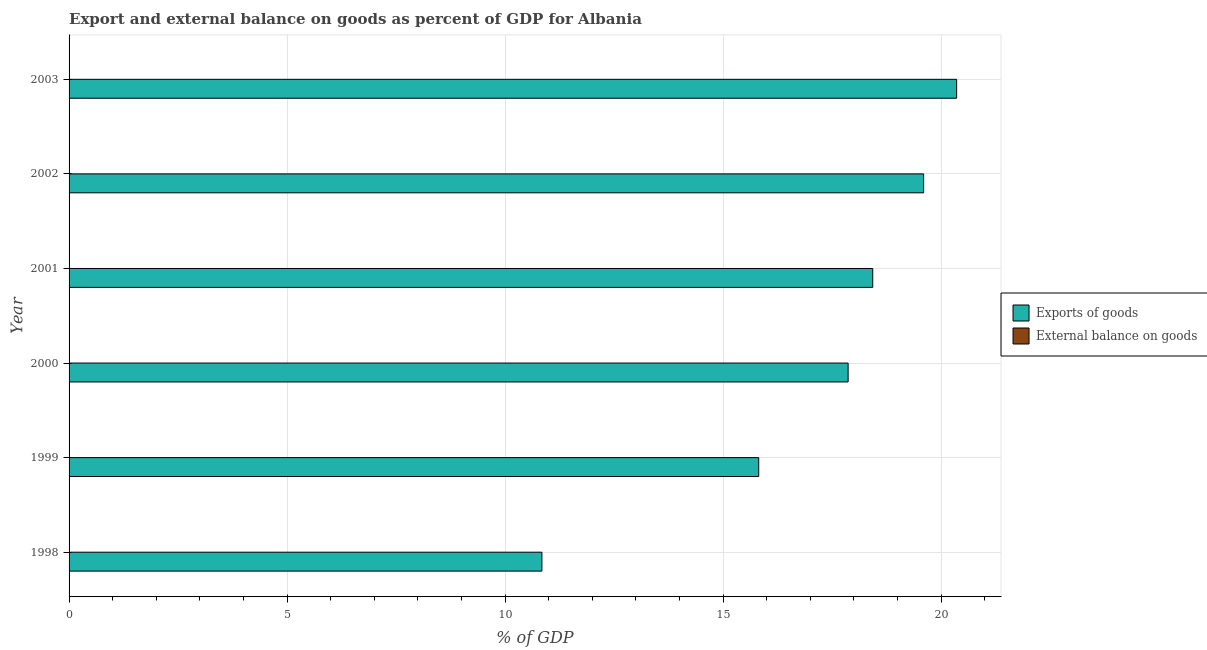Are the number of bars per tick equal to the number of legend labels?
Ensure brevity in your answer.  No. How many bars are there on the 5th tick from the top?
Keep it short and to the point. 1. What is the export of goods as percentage of gdp in 2002?
Offer a very short reply. 19.6. Across all years, what is the maximum export of goods as percentage of gdp?
Your answer should be compact. 20.36. In which year was the export of goods as percentage of gdp maximum?
Offer a very short reply. 2003. What is the total external balance on goods as percentage of gdp in the graph?
Provide a succinct answer. 0. What is the difference between the export of goods as percentage of gdp in 1999 and that in 2000?
Offer a terse response. -2.05. What is the difference between the external balance on goods as percentage of gdp in 2001 and the export of goods as percentage of gdp in 2002?
Provide a succinct answer. -19.6. What is the average export of goods as percentage of gdp per year?
Offer a terse response. 17.15. What is the ratio of the export of goods as percentage of gdp in 2000 to that in 2002?
Ensure brevity in your answer.  0.91. Is the export of goods as percentage of gdp in 2001 less than that in 2003?
Your answer should be compact. Yes. What is the difference between the highest and the second highest export of goods as percentage of gdp?
Offer a terse response. 0.76. What is the difference between the highest and the lowest export of goods as percentage of gdp?
Ensure brevity in your answer.  9.51. In how many years, is the export of goods as percentage of gdp greater than the average export of goods as percentage of gdp taken over all years?
Give a very brief answer. 4. Are all the bars in the graph horizontal?
Your answer should be compact. Yes. How many years are there in the graph?
Provide a succinct answer. 6. What is the difference between two consecutive major ticks on the X-axis?
Provide a succinct answer. 5. Does the graph contain any zero values?
Ensure brevity in your answer.  Yes. Where does the legend appear in the graph?
Provide a succinct answer. Center right. How many legend labels are there?
Provide a succinct answer. 2. How are the legend labels stacked?
Keep it short and to the point. Vertical. What is the title of the graph?
Provide a short and direct response. Export and external balance on goods as percent of GDP for Albania. What is the label or title of the X-axis?
Make the answer very short. % of GDP. What is the label or title of the Y-axis?
Your answer should be compact. Year. What is the % of GDP in Exports of goods in 1998?
Provide a succinct answer. 10.84. What is the % of GDP in External balance on goods in 1998?
Your answer should be very brief. 0. What is the % of GDP in Exports of goods in 1999?
Keep it short and to the point. 15.82. What is the % of GDP of External balance on goods in 1999?
Ensure brevity in your answer.  0. What is the % of GDP of Exports of goods in 2000?
Offer a very short reply. 17.87. What is the % of GDP of External balance on goods in 2000?
Your answer should be compact. 0. What is the % of GDP of Exports of goods in 2001?
Your answer should be very brief. 18.43. What is the % of GDP of External balance on goods in 2001?
Your answer should be compact. 0. What is the % of GDP of Exports of goods in 2002?
Give a very brief answer. 19.6. What is the % of GDP in External balance on goods in 2002?
Your answer should be very brief. 0. What is the % of GDP of Exports of goods in 2003?
Provide a short and direct response. 20.36. Across all years, what is the maximum % of GDP in Exports of goods?
Your answer should be very brief. 20.36. Across all years, what is the minimum % of GDP of Exports of goods?
Your answer should be compact. 10.84. What is the total % of GDP of Exports of goods in the graph?
Your answer should be compact. 102.91. What is the total % of GDP of External balance on goods in the graph?
Provide a succinct answer. 0. What is the difference between the % of GDP of Exports of goods in 1998 and that in 1999?
Your answer should be very brief. -4.97. What is the difference between the % of GDP in Exports of goods in 1998 and that in 2000?
Your response must be concise. -7.02. What is the difference between the % of GDP of Exports of goods in 1998 and that in 2001?
Your answer should be compact. -7.59. What is the difference between the % of GDP of Exports of goods in 1998 and that in 2002?
Make the answer very short. -8.75. What is the difference between the % of GDP in Exports of goods in 1998 and that in 2003?
Provide a succinct answer. -9.51. What is the difference between the % of GDP in Exports of goods in 1999 and that in 2000?
Offer a very short reply. -2.05. What is the difference between the % of GDP in Exports of goods in 1999 and that in 2001?
Offer a very short reply. -2.61. What is the difference between the % of GDP in Exports of goods in 1999 and that in 2002?
Keep it short and to the point. -3.78. What is the difference between the % of GDP of Exports of goods in 1999 and that in 2003?
Offer a terse response. -4.54. What is the difference between the % of GDP of Exports of goods in 2000 and that in 2001?
Make the answer very short. -0.56. What is the difference between the % of GDP in Exports of goods in 2000 and that in 2002?
Your response must be concise. -1.73. What is the difference between the % of GDP in Exports of goods in 2000 and that in 2003?
Keep it short and to the point. -2.49. What is the difference between the % of GDP in Exports of goods in 2001 and that in 2002?
Your answer should be very brief. -1.17. What is the difference between the % of GDP in Exports of goods in 2001 and that in 2003?
Give a very brief answer. -1.92. What is the difference between the % of GDP in Exports of goods in 2002 and that in 2003?
Make the answer very short. -0.76. What is the average % of GDP of Exports of goods per year?
Your answer should be very brief. 17.15. What is the ratio of the % of GDP of Exports of goods in 1998 to that in 1999?
Offer a very short reply. 0.69. What is the ratio of the % of GDP in Exports of goods in 1998 to that in 2000?
Your answer should be very brief. 0.61. What is the ratio of the % of GDP of Exports of goods in 1998 to that in 2001?
Offer a very short reply. 0.59. What is the ratio of the % of GDP of Exports of goods in 1998 to that in 2002?
Offer a terse response. 0.55. What is the ratio of the % of GDP in Exports of goods in 1998 to that in 2003?
Give a very brief answer. 0.53. What is the ratio of the % of GDP of Exports of goods in 1999 to that in 2000?
Keep it short and to the point. 0.89. What is the ratio of the % of GDP of Exports of goods in 1999 to that in 2001?
Provide a succinct answer. 0.86. What is the ratio of the % of GDP of Exports of goods in 1999 to that in 2002?
Ensure brevity in your answer.  0.81. What is the ratio of the % of GDP in Exports of goods in 1999 to that in 2003?
Offer a very short reply. 0.78. What is the ratio of the % of GDP in Exports of goods in 2000 to that in 2001?
Give a very brief answer. 0.97. What is the ratio of the % of GDP of Exports of goods in 2000 to that in 2002?
Make the answer very short. 0.91. What is the ratio of the % of GDP of Exports of goods in 2000 to that in 2003?
Keep it short and to the point. 0.88. What is the ratio of the % of GDP of Exports of goods in 2001 to that in 2002?
Give a very brief answer. 0.94. What is the ratio of the % of GDP in Exports of goods in 2001 to that in 2003?
Make the answer very short. 0.91. What is the ratio of the % of GDP in Exports of goods in 2002 to that in 2003?
Keep it short and to the point. 0.96. What is the difference between the highest and the second highest % of GDP of Exports of goods?
Keep it short and to the point. 0.76. What is the difference between the highest and the lowest % of GDP in Exports of goods?
Provide a short and direct response. 9.51. 